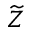<formula> <loc_0><loc_0><loc_500><loc_500>\widetilde { Z }</formula> 